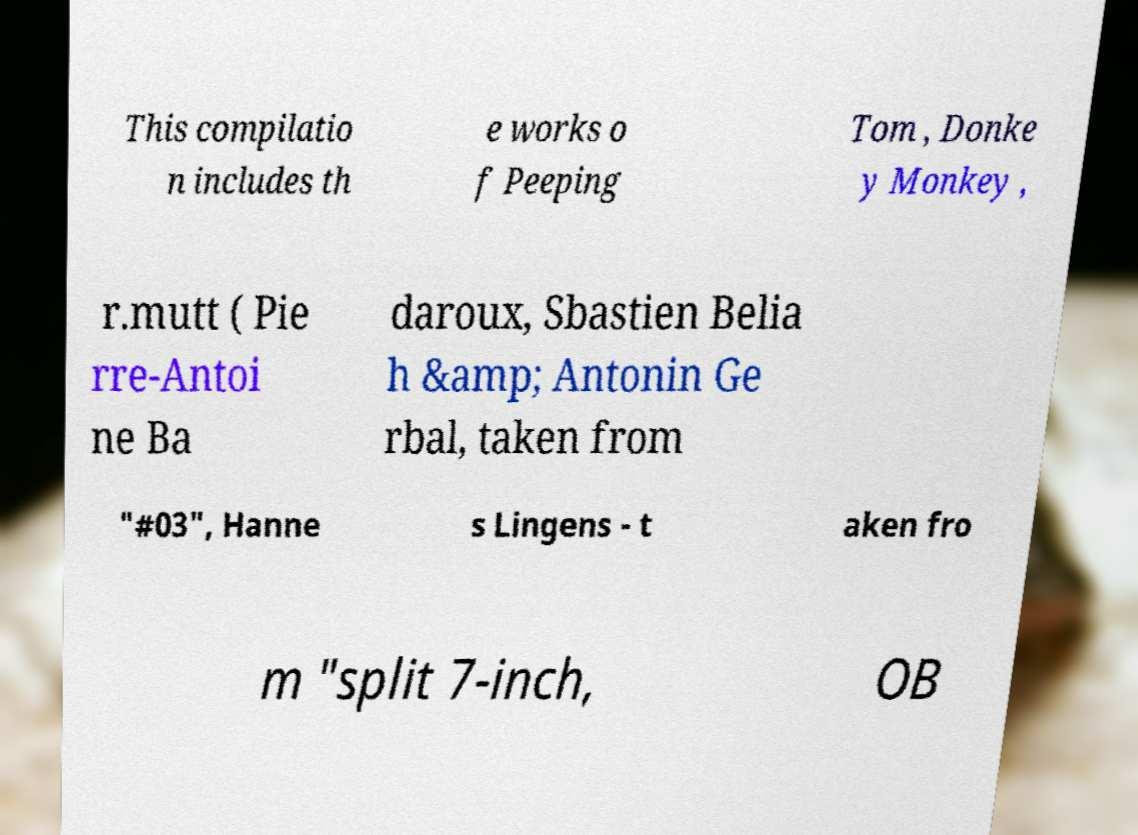What messages or text are displayed in this image? I need them in a readable, typed format. This compilatio n includes th e works o f Peeping Tom , Donke y Monkey , r.mutt ( Pie rre-Antoi ne Ba daroux, Sbastien Belia h &amp; Antonin Ge rbal, taken from "#03", Hanne s Lingens - t aken fro m "split 7-inch, OB 